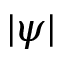Convert formula to latex. <formula><loc_0><loc_0><loc_500><loc_500>| \psi |</formula> 